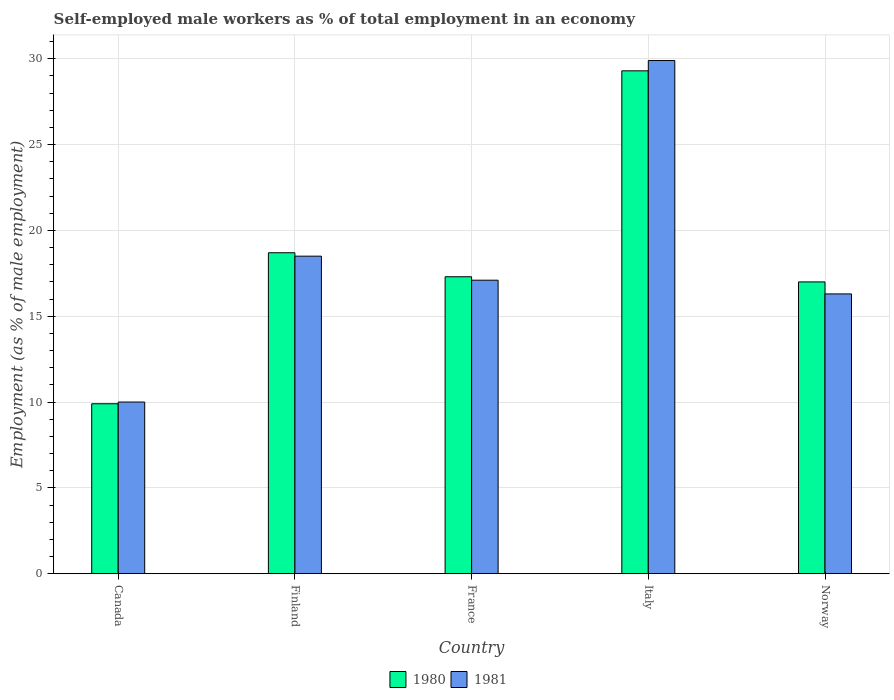How many different coloured bars are there?
Your answer should be compact. 2. Are the number of bars per tick equal to the number of legend labels?
Give a very brief answer. Yes. How many bars are there on the 4th tick from the left?
Your response must be concise. 2. What is the percentage of self-employed male workers in 1981 in France?
Keep it short and to the point. 17.1. Across all countries, what is the maximum percentage of self-employed male workers in 1981?
Offer a very short reply. 29.9. Across all countries, what is the minimum percentage of self-employed male workers in 1981?
Make the answer very short. 10. In which country was the percentage of self-employed male workers in 1981 maximum?
Provide a succinct answer. Italy. In which country was the percentage of self-employed male workers in 1980 minimum?
Offer a very short reply. Canada. What is the total percentage of self-employed male workers in 1981 in the graph?
Your response must be concise. 91.8. What is the difference between the percentage of self-employed male workers in 1981 in Canada and that in France?
Provide a short and direct response. -7.1. What is the difference between the percentage of self-employed male workers in 1981 in Italy and the percentage of self-employed male workers in 1980 in Canada?
Make the answer very short. 20. What is the average percentage of self-employed male workers in 1980 per country?
Give a very brief answer. 18.44. What is the difference between the percentage of self-employed male workers of/in 1981 and percentage of self-employed male workers of/in 1980 in Norway?
Give a very brief answer. -0.7. In how many countries, is the percentage of self-employed male workers in 1981 greater than 22 %?
Your answer should be very brief. 1. What is the ratio of the percentage of self-employed male workers in 1980 in Italy to that in Norway?
Offer a terse response. 1.72. Is the percentage of self-employed male workers in 1981 in Canada less than that in Finland?
Provide a short and direct response. Yes. Is the difference between the percentage of self-employed male workers in 1981 in Canada and Italy greater than the difference between the percentage of self-employed male workers in 1980 in Canada and Italy?
Give a very brief answer. No. What is the difference between the highest and the second highest percentage of self-employed male workers in 1980?
Your response must be concise. -1.4. What is the difference between the highest and the lowest percentage of self-employed male workers in 1981?
Offer a very short reply. 19.9. In how many countries, is the percentage of self-employed male workers in 1981 greater than the average percentage of self-employed male workers in 1981 taken over all countries?
Give a very brief answer. 2. What does the 2nd bar from the left in France represents?
Provide a short and direct response. 1981. Are all the bars in the graph horizontal?
Your answer should be very brief. No. How many countries are there in the graph?
Provide a short and direct response. 5. Does the graph contain any zero values?
Offer a terse response. No. Where does the legend appear in the graph?
Ensure brevity in your answer.  Bottom center. How many legend labels are there?
Provide a short and direct response. 2. What is the title of the graph?
Ensure brevity in your answer.  Self-employed male workers as % of total employment in an economy. Does "1971" appear as one of the legend labels in the graph?
Keep it short and to the point. No. What is the label or title of the Y-axis?
Make the answer very short. Employment (as % of male employment). What is the Employment (as % of male employment) in 1980 in Canada?
Your response must be concise. 9.9. What is the Employment (as % of male employment) in 1980 in Finland?
Keep it short and to the point. 18.7. What is the Employment (as % of male employment) of 1980 in France?
Make the answer very short. 17.3. What is the Employment (as % of male employment) in 1981 in France?
Provide a succinct answer. 17.1. What is the Employment (as % of male employment) in 1980 in Italy?
Offer a terse response. 29.3. What is the Employment (as % of male employment) in 1981 in Italy?
Provide a short and direct response. 29.9. What is the Employment (as % of male employment) of 1980 in Norway?
Give a very brief answer. 17. What is the Employment (as % of male employment) in 1981 in Norway?
Offer a terse response. 16.3. Across all countries, what is the maximum Employment (as % of male employment) in 1980?
Your answer should be very brief. 29.3. Across all countries, what is the maximum Employment (as % of male employment) of 1981?
Offer a terse response. 29.9. Across all countries, what is the minimum Employment (as % of male employment) of 1980?
Provide a short and direct response. 9.9. What is the total Employment (as % of male employment) in 1980 in the graph?
Provide a succinct answer. 92.2. What is the total Employment (as % of male employment) of 1981 in the graph?
Provide a short and direct response. 91.8. What is the difference between the Employment (as % of male employment) in 1981 in Canada and that in Finland?
Your answer should be very brief. -8.5. What is the difference between the Employment (as % of male employment) of 1980 in Canada and that in France?
Give a very brief answer. -7.4. What is the difference between the Employment (as % of male employment) in 1980 in Canada and that in Italy?
Give a very brief answer. -19.4. What is the difference between the Employment (as % of male employment) in 1981 in Canada and that in Italy?
Your answer should be compact. -19.9. What is the difference between the Employment (as % of male employment) in 1981 in Finland and that in France?
Your response must be concise. 1.4. What is the difference between the Employment (as % of male employment) in 1980 in Finland and that in Italy?
Provide a succinct answer. -10.6. What is the difference between the Employment (as % of male employment) in 1980 in Finland and that in Norway?
Give a very brief answer. 1.7. What is the difference between the Employment (as % of male employment) of 1981 in France and that in Norway?
Offer a very short reply. 0.8. What is the difference between the Employment (as % of male employment) of 1980 in Italy and that in Norway?
Give a very brief answer. 12.3. What is the difference between the Employment (as % of male employment) of 1980 in Canada and the Employment (as % of male employment) of 1981 in Finland?
Your response must be concise. -8.6. What is the difference between the Employment (as % of male employment) in 1980 in Finland and the Employment (as % of male employment) in 1981 in Italy?
Make the answer very short. -11.2. What is the difference between the Employment (as % of male employment) of 1980 in Finland and the Employment (as % of male employment) of 1981 in Norway?
Make the answer very short. 2.4. What is the difference between the Employment (as % of male employment) of 1980 in France and the Employment (as % of male employment) of 1981 in Italy?
Give a very brief answer. -12.6. What is the average Employment (as % of male employment) of 1980 per country?
Offer a terse response. 18.44. What is the average Employment (as % of male employment) of 1981 per country?
Offer a terse response. 18.36. What is the difference between the Employment (as % of male employment) in 1980 and Employment (as % of male employment) in 1981 in Finland?
Provide a succinct answer. 0.2. What is the difference between the Employment (as % of male employment) in 1980 and Employment (as % of male employment) in 1981 in France?
Make the answer very short. 0.2. What is the difference between the Employment (as % of male employment) of 1980 and Employment (as % of male employment) of 1981 in Italy?
Your response must be concise. -0.6. What is the ratio of the Employment (as % of male employment) in 1980 in Canada to that in Finland?
Keep it short and to the point. 0.53. What is the ratio of the Employment (as % of male employment) of 1981 in Canada to that in Finland?
Your response must be concise. 0.54. What is the ratio of the Employment (as % of male employment) of 1980 in Canada to that in France?
Ensure brevity in your answer.  0.57. What is the ratio of the Employment (as % of male employment) in 1981 in Canada to that in France?
Offer a very short reply. 0.58. What is the ratio of the Employment (as % of male employment) of 1980 in Canada to that in Italy?
Provide a short and direct response. 0.34. What is the ratio of the Employment (as % of male employment) of 1981 in Canada to that in Italy?
Offer a terse response. 0.33. What is the ratio of the Employment (as % of male employment) in 1980 in Canada to that in Norway?
Provide a succinct answer. 0.58. What is the ratio of the Employment (as % of male employment) of 1981 in Canada to that in Norway?
Provide a succinct answer. 0.61. What is the ratio of the Employment (as % of male employment) in 1980 in Finland to that in France?
Offer a very short reply. 1.08. What is the ratio of the Employment (as % of male employment) in 1981 in Finland to that in France?
Your answer should be very brief. 1.08. What is the ratio of the Employment (as % of male employment) in 1980 in Finland to that in Italy?
Give a very brief answer. 0.64. What is the ratio of the Employment (as % of male employment) of 1981 in Finland to that in Italy?
Your response must be concise. 0.62. What is the ratio of the Employment (as % of male employment) of 1980 in Finland to that in Norway?
Provide a short and direct response. 1.1. What is the ratio of the Employment (as % of male employment) in 1981 in Finland to that in Norway?
Give a very brief answer. 1.14. What is the ratio of the Employment (as % of male employment) of 1980 in France to that in Italy?
Give a very brief answer. 0.59. What is the ratio of the Employment (as % of male employment) of 1981 in France to that in Italy?
Provide a succinct answer. 0.57. What is the ratio of the Employment (as % of male employment) in 1980 in France to that in Norway?
Keep it short and to the point. 1.02. What is the ratio of the Employment (as % of male employment) in 1981 in France to that in Norway?
Your answer should be compact. 1.05. What is the ratio of the Employment (as % of male employment) in 1980 in Italy to that in Norway?
Your answer should be compact. 1.72. What is the ratio of the Employment (as % of male employment) in 1981 in Italy to that in Norway?
Offer a very short reply. 1.83. What is the difference between the highest and the second highest Employment (as % of male employment) in 1980?
Your answer should be very brief. 10.6. What is the difference between the highest and the lowest Employment (as % of male employment) in 1980?
Your answer should be compact. 19.4. What is the difference between the highest and the lowest Employment (as % of male employment) in 1981?
Offer a very short reply. 19.9. 